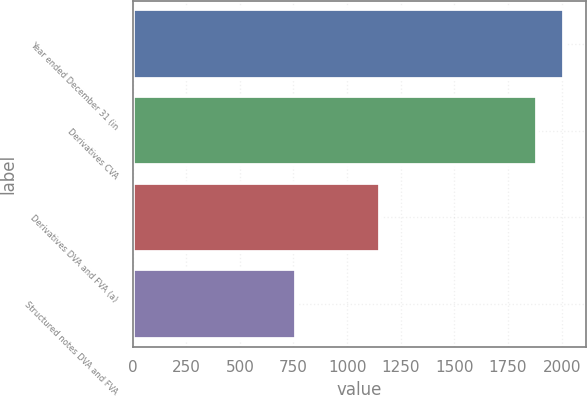<chart> <loc_0><loc_0><loc_500><loc_500><bar_chart><fcel>Year ended December 31 (in<fcel>Derivatives CVA<fcel>Derivatives DVA and FVA (a)<fcel>Structured notes DVA and FVA<nl><fcel>2013<fcel>1886<fcel>1152<fcel>760<nl></chart> 